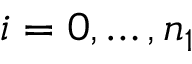<formula> <loc_0><loc_0><loc_500><loc_500>i = 0 , \dots , n _ { 1 }</formula> 